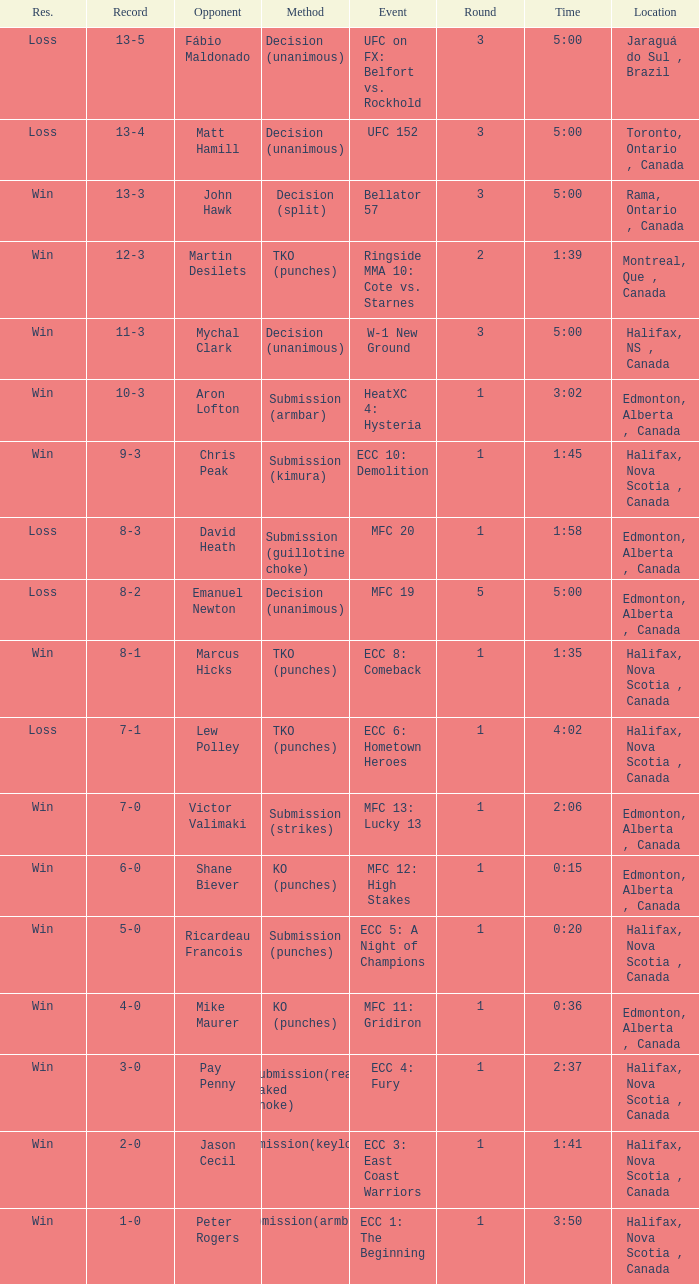What is the location of the match with Aron Lofton as the opponent? Edmonton, Alberta , Canada. 